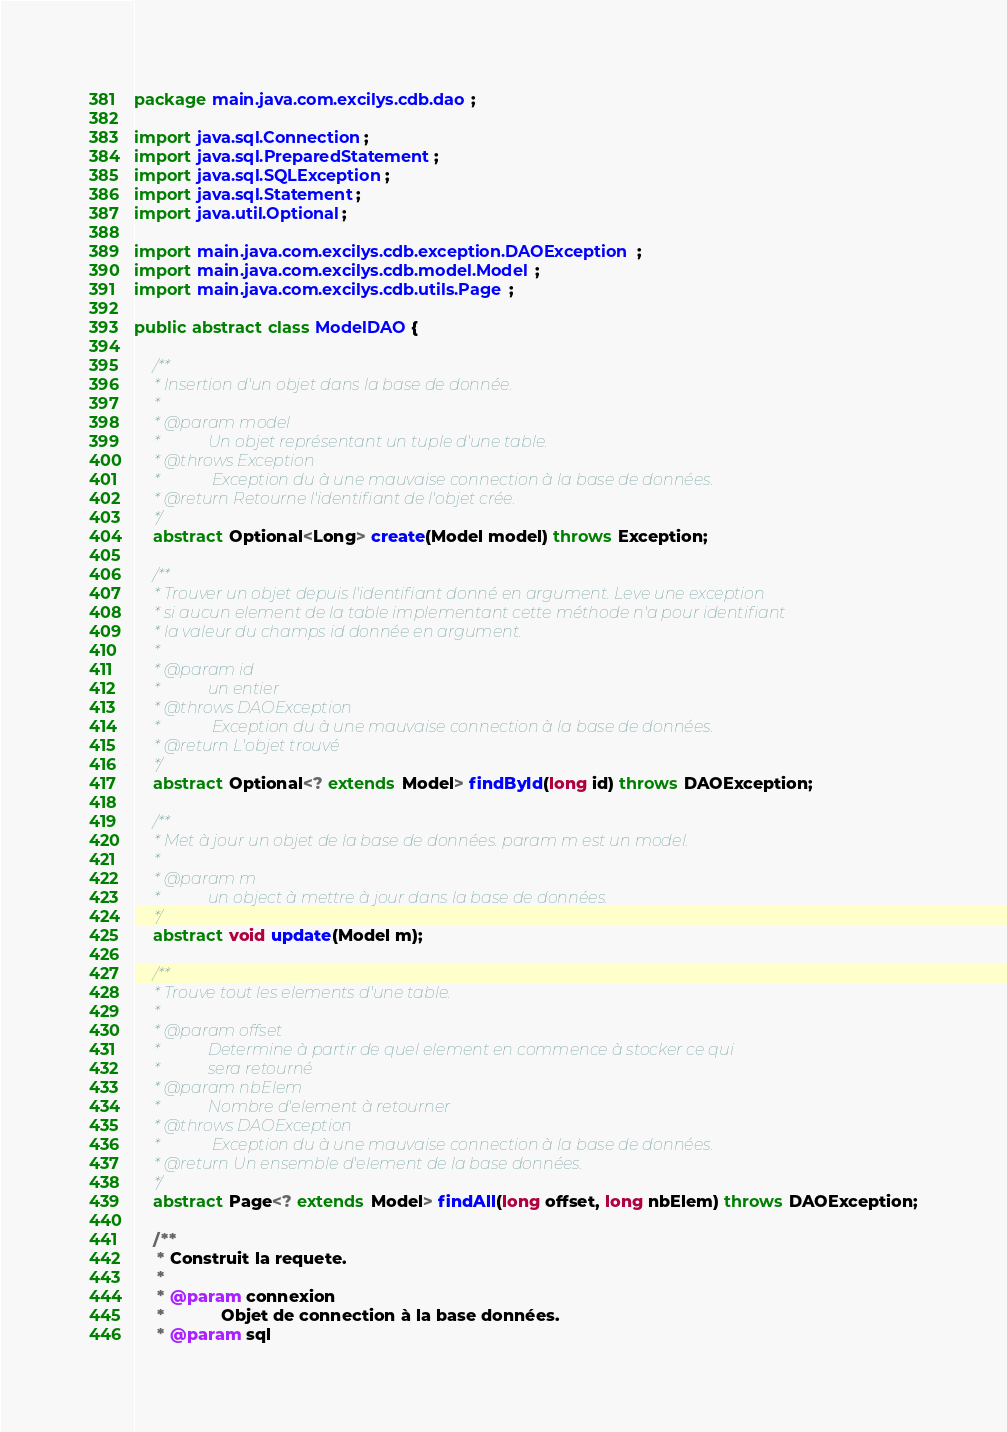<code> <loc_0><loc_0><loc_500><loc_500><_Java_>package main.java.com.excilys.cdb.dao;

import java.sql.Connection;
import java.sql.PreparedStatement;
import java.sql.SQLException;
import java.sql.Statement;
import java.util.Optional;

import main.java.com.excilys.cdb.exception.DAOException;
import main.java.com.excilys.cdb.model.Model;
import main.java.com.excilys.cdb.utils.Page;

public abstract class ModelDAO {

	/**
	 * Insertion d'un objet dans la base de donnée.
	 * 
	 * @param model
	 *            Un objet représentant un tuple d'une table.
	 * @throws Exception
	 *             Exception du à une mauvaise connection à la base de données.
	 * @return Retourne l'identifiant de l'objet crée.
	 */
	abstract Optional<Long> create(Model model) throws Exception;

	/**
	 * Trouver un objet depuis l'identifiant donné en argument. Leve une exception
	 * si aucun element de la table implementant cette méthode n'a pour identifiant
	 * la valeur du champs id donnée en argument.
	 * 
	 * @param id
	 *            un entier
	 * @throws DAOException
	 *             Exception du à une mauvaise connection à la base de données.
	 * @return L'objet trouvé
	 */
	abstract Optional<? extends Model> findById(long id) throws DAOException;

	/**
	 * Met à jour un objet de la base de données. param m est un model.
	 * 
	 * @param m
	 *            un object à mettre à jour dans la base de données.
	 */
	abstract void update(Model m);

	/**
	 * Trouve tout les elements d'une table.
	 * 
	 * @param offset
	 *            Determine à partir de quel element en commence à stocker ce qui
	 *            sera retourné
	 * @param nbElem
	 *            Nombre d'element à retourner
	 * @throws DAOException
	 *             Exception du à une mauvaise connection à la base de données.
	 * @return Un ensemble d'element de la base données.
	 */
	abstract Page<? extends Model> findAll(long offset, long nbElem) throws DAOException;

	/**
	 * Construit la requete.
	 * 
	 * @param connexion
	 *            Objet de connection à la base données.
	 * @param sql</code> 